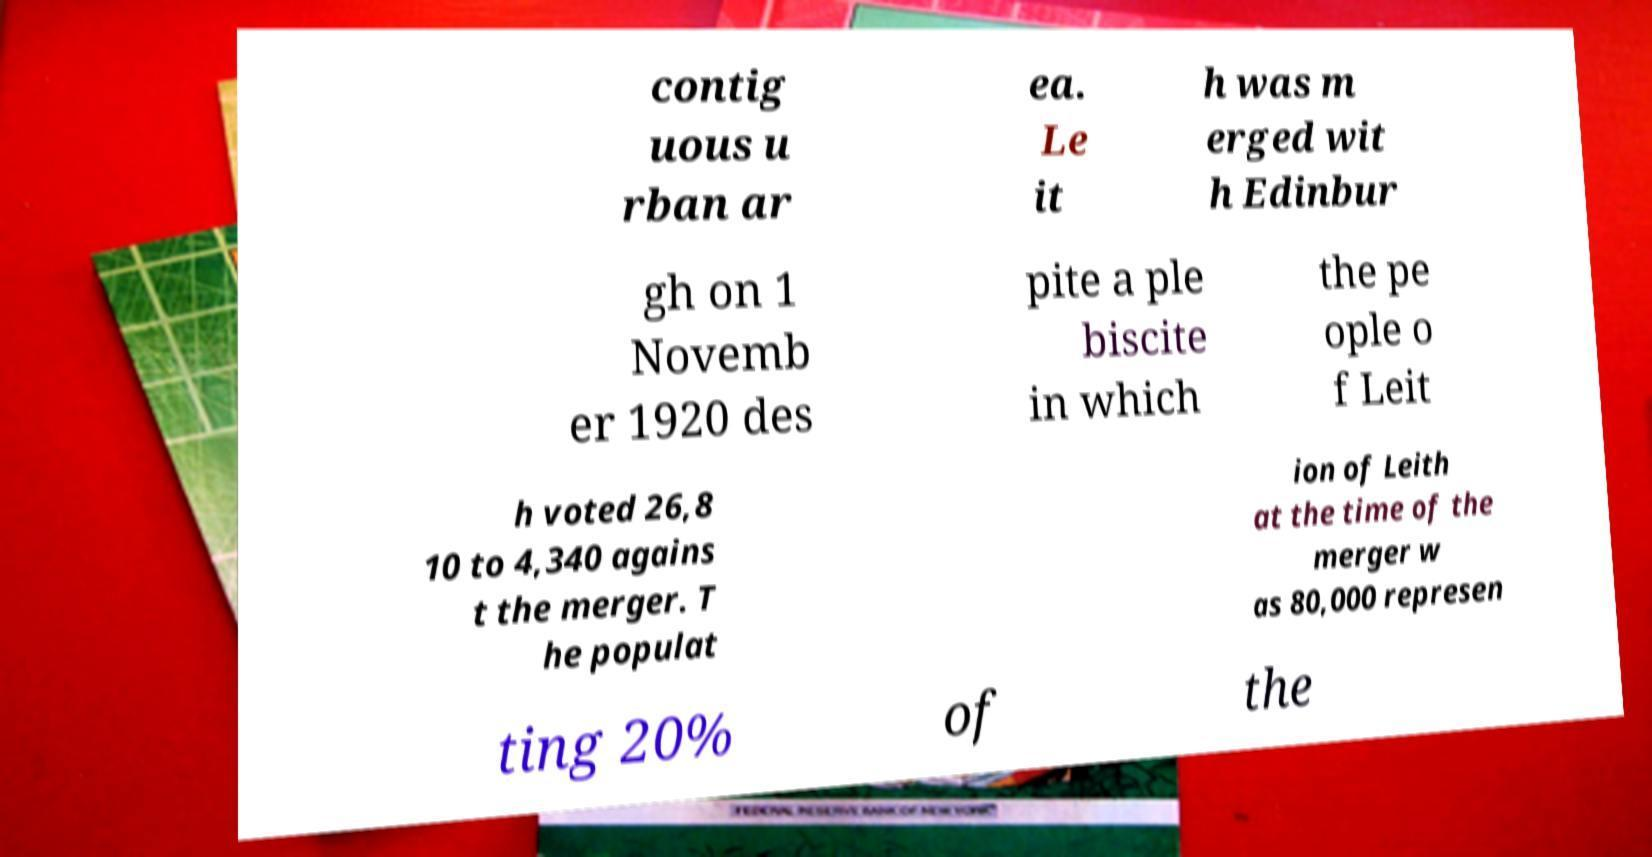Please read and relay the text visible in this image. What does it say? contig uous u rban ar ea. Le it h was m erged wit h Edinbur gh on 1 Novemb er 1920 des pite a ple biscite in which the pe ople o f Leit h voted 26,8 10 to 4,340 agains t the merger. T he populat ion of Leith at the time of the merger w as 80,000 represen ting 20% of the 